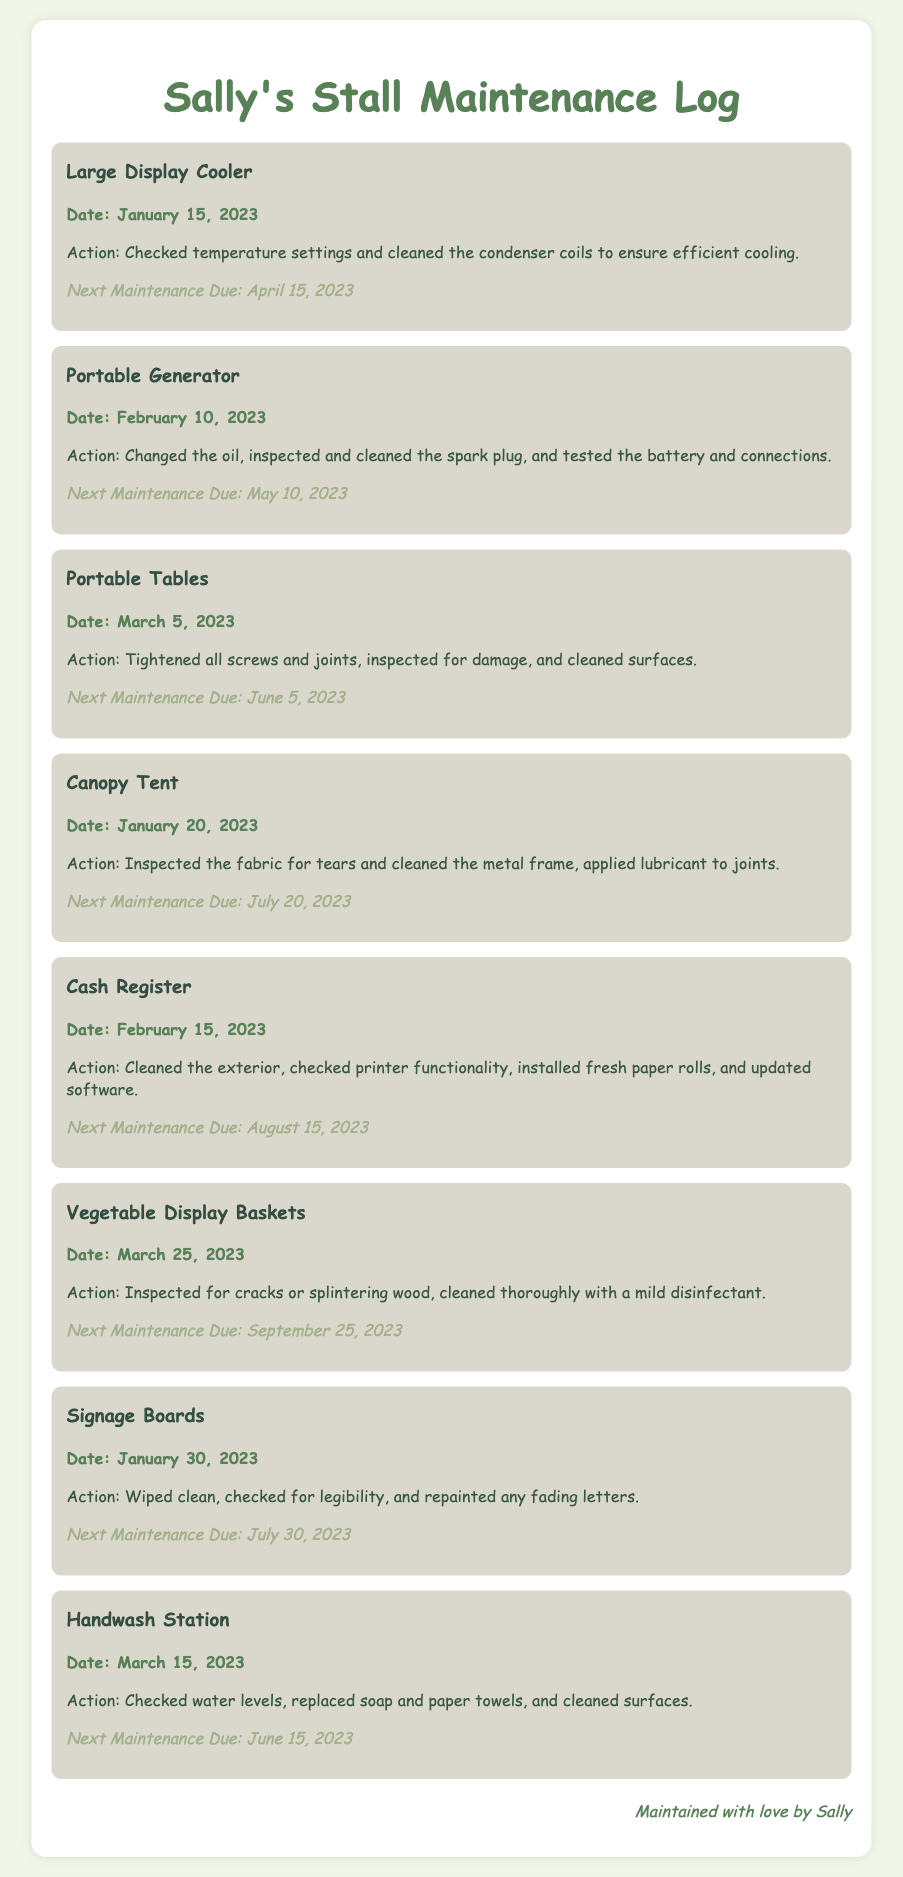What was the last maintenance date for the Large Display Cooler? The last maintenance date for the Large Display Cooler is stated in the log as January 15, 2023.
Answer: January 15, 2023 When is the next maintenance due for the Cash Register? The next maintenance due date for the Cash Register is mentioned in the document as August 15, 2023.
Answer: August 15, 2023 What action was taken for the Portable Generator? The action taken for the Portable Generator includes changing the oil, inspecting and cleaning the spark plug, and testing the battery and connections, as stated in the log.
Answer: Changed the oil, inspected and cleaned the spark plug, tested the battery and connections How often is maintenance required for the Canopy Tent? The maintenance for the Canopy Tent is noted to be due every six months in the document.
Answer: Every six months Which item had its maintenance logged on March 5, 2023? The item that had its maintenance logged on March 5, 2023, is the Portable Tables, as clearly indicated in the maintenance log.
Answer: Portable Tables What was checked during the maintenance of the Handwash Station? The Handwash Station maintenance involved checking water levels, replacing soap and paper towels, and cleaning surfaces.
Answer: Checked water levels, replaced soap and paper towels, cleaned surfaces What color is used for headings in the maintenance log? The color used for headings in the maintenance log is specifically stated as a shade of green.
Answer: Green What maintenance action is specific to the Vegetable Display Baskets? The specific action taken for the Vegetable Display Baskets is inspecting for cracks or splintering wood and cleaning with a mild disinfectant.
Answer: Inspected for cracks or splintering wood, cleaned with disinfectant 